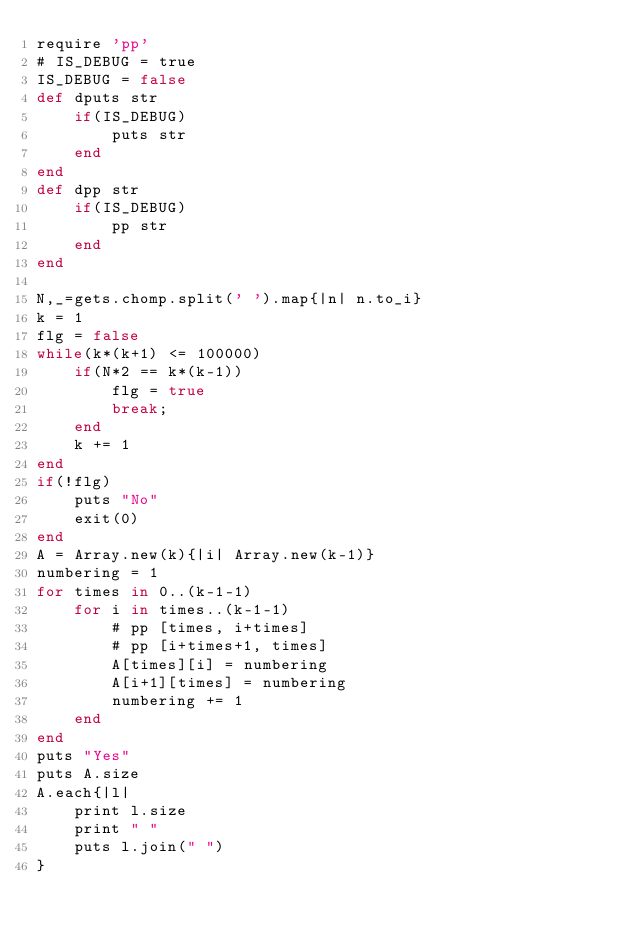<code> <loc_0><loc_0><loc_500><loc_500><_Ruby_>require 'pp'
# IS_DEBUG = true
IS_DEBUG = false
def dputs str
	if(IS_DEBUG)
		puts str
	end
end
def dpp str
	if(IS_DEBUG)
		pp str
	end
end

N,_=gets.chomp.split(' ').map{|n| n.to_i}
k = 1
flg = false
while(k*(k+1) <= 100000)
	if(N*2 == k*(k-1))
		flg = true
		break;
	end
	k += 1
end
if(!flg)
	puts "No"
	exit(0)
end
A = Array.new(k){|i| Array.new(k-1)}
numbering = 1
for times in 0..(k-1-1)
	for i in times..(k-1-1)
		# pp [times, i+times]
		# pp [i+times+1, times]
		A[times][i] = numbering
		A[i+1][times] = numbering
		numbering += 1
	end
end
puts "Yes"
puts A.size
A.each{|l|
	print l.size
	print " "
	puts l.join(" ")
}
</code> 